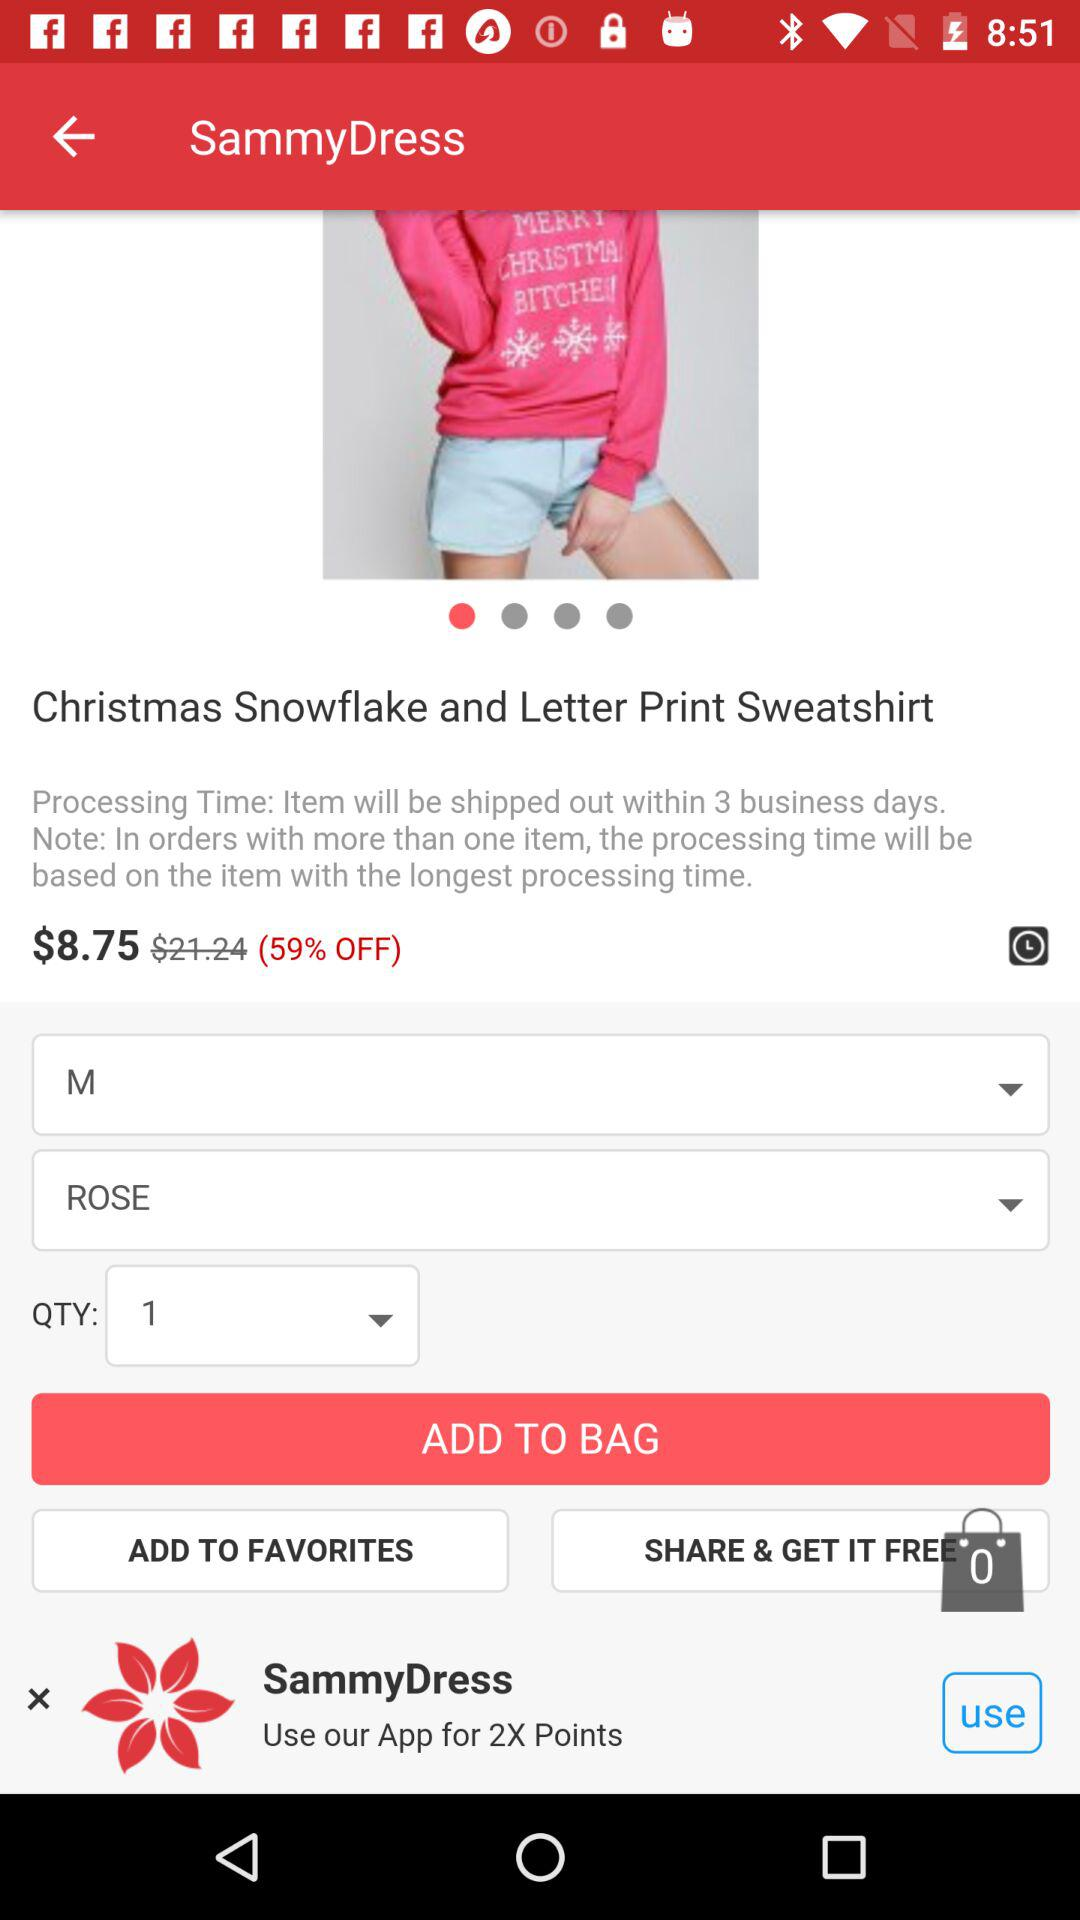What is the original price of the product?
Answer the question using a single word or phrase. $21.24 